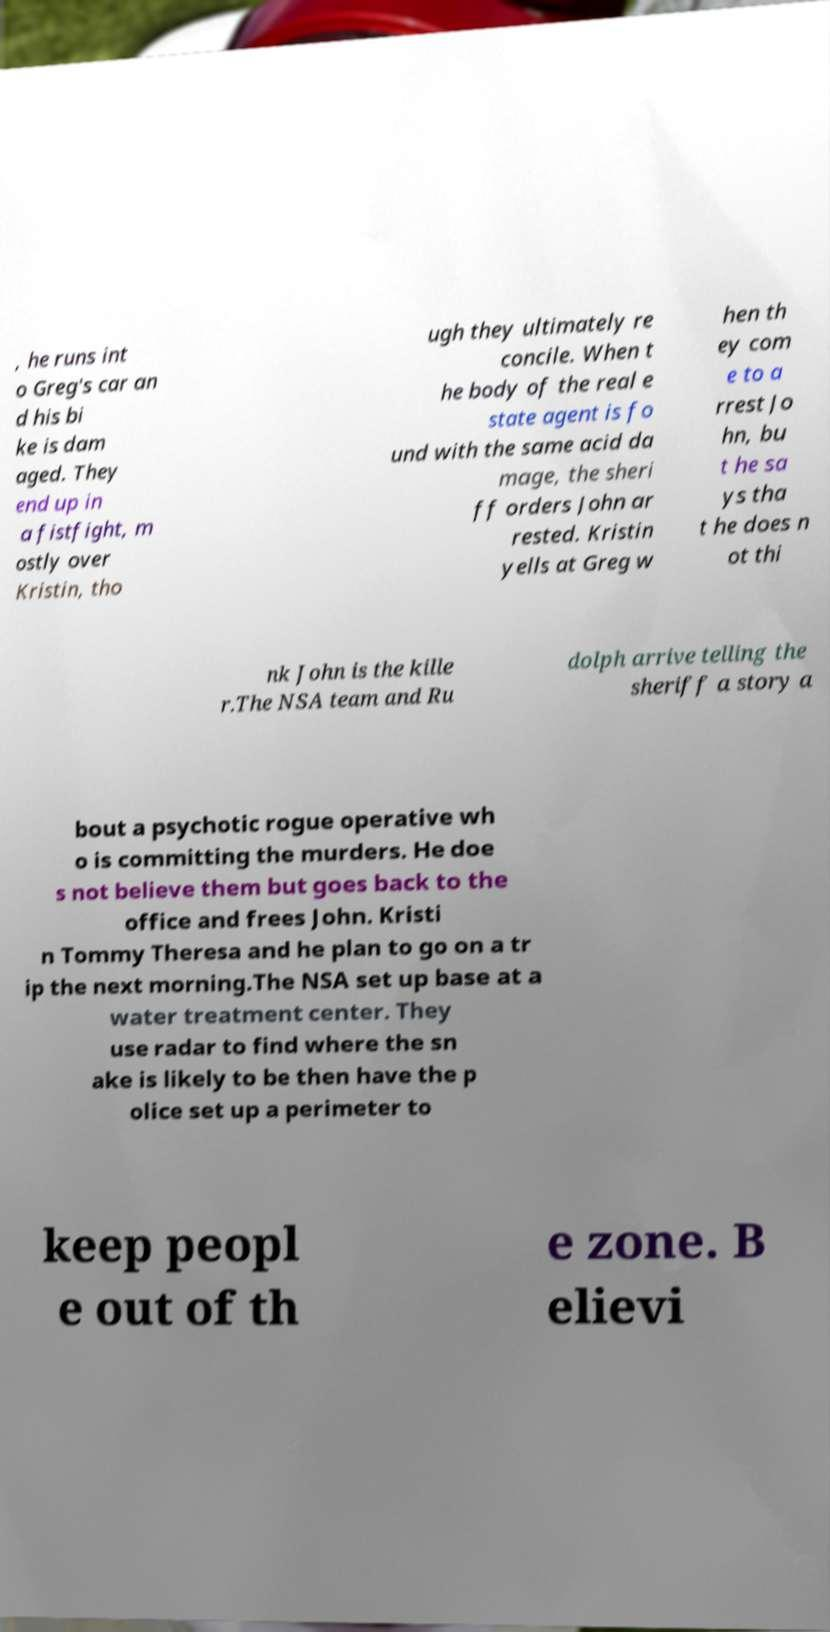Can you read and provide the text displayed in the image?This photo seems to have some interesting text. Can you extract and type it out for me? , he runs int o Greg's car an d his bi ke is dam aged. They end up in a fistfight, m ostly over Kristin, tho ugh they ultimately re concile. When t he body of the real e state agent is fo und with the same acid da mage, the sheri ff orders John ar rested. Kristin yells at Greg w hen th ey com e to a rrest Jo hn, bu t he sa ys tha t he does n ot thi nk John is the kille r.The NSA team and Ru dolph arrive telling the sheriff a story a bout a psychotic rogue operative wh o is committing the murders. He doe s not believe them but goes back to the office and frees John. Kristi n Tommy Theresa and he plan to go on a tr ip the next morning.The NSA set up base at a water treatment center. They use radar to find where the sn ake is likely to be then have the p olice set up a perimeter to keep peopl e out of th e zone. B elievi 